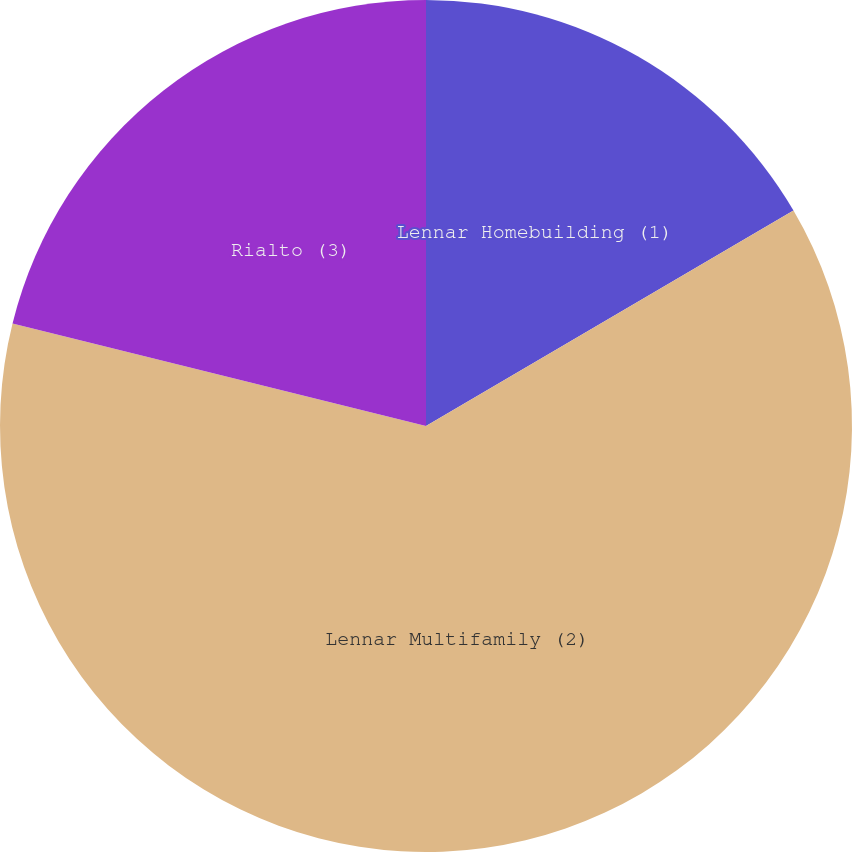<chart> <loc_0><loc_0><loc_500><loc_500><pie_chart><fcel>Lennar Homebuilding (1)<fcel>Lennar Multifamily (2)<fcel>Rialto (3)<nl><fcel>16.56%<fcel>62.31%<fcel>21.13%<nl></chart> 